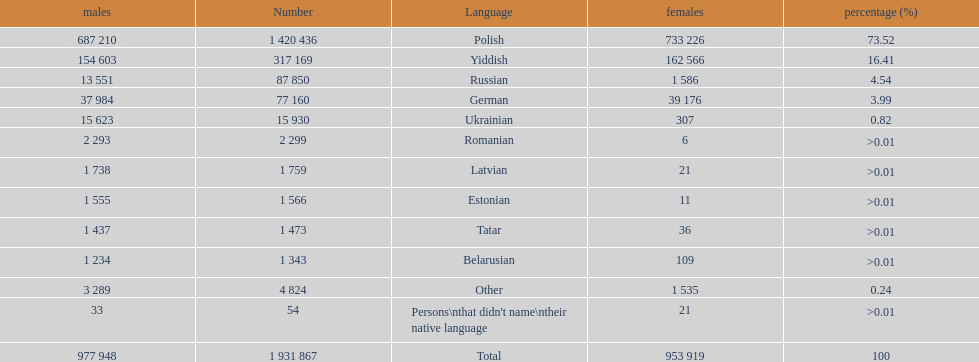The least amount of females Romanian. 